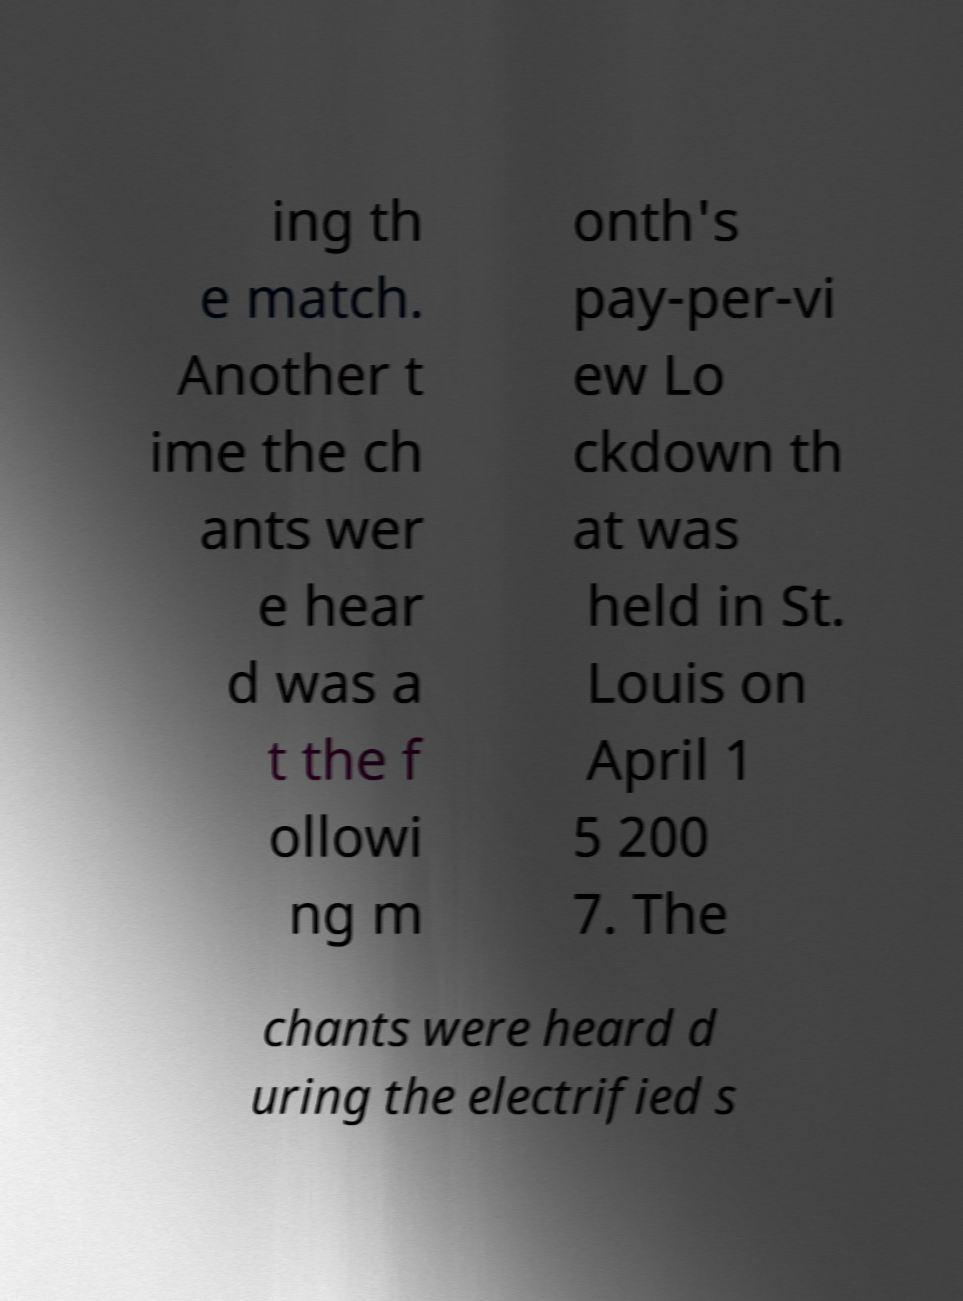For documentation purposes, I need the text within this image transcribed. Could you provide that? ing th e match. Another t ime the ch ants wer e hear d was a t the f ollowi ng m onth's pay-per-vi ew Lo ckdown th at was held in St. Louis on April 1 5 200 7. The chants were heard d uring the electrified s 